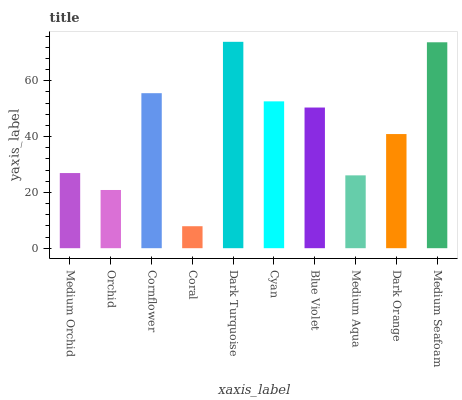Is Coral the minimum?
Answer yes or no. Yes. Is Dark Turquoise the maximum?
Answer yes or no. Yes. Is Orchid the minimum?
Answer yes or no. No. Is Orchid the maximum?
Answer yes or no. No. Is Medium Orchid greater than Orchid?
Answer yes or no. Yes. Is Orchid less than Medium Orchid?
Answer yes or no. Yes. Is Orchid greater than Medium Orchid?
Answer yes or no. No. Is Medium Orchid less than Orchid?
Answer yes or no. No. Is Blue Violet the high median?
Answer yes or no. Yes. Is Dark Orange the low median?
Answer yes or no. Yes. Is Medium Aqua the high median?
Answer yes or no. No. Is Orchid the low median?
Answer yes or no. No. 